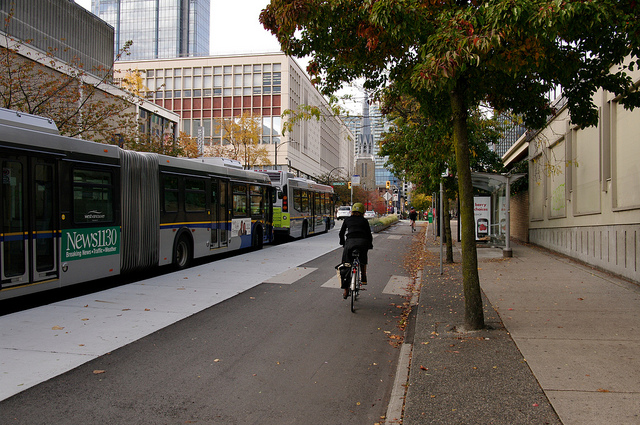Please identify all text content in this image. News1 